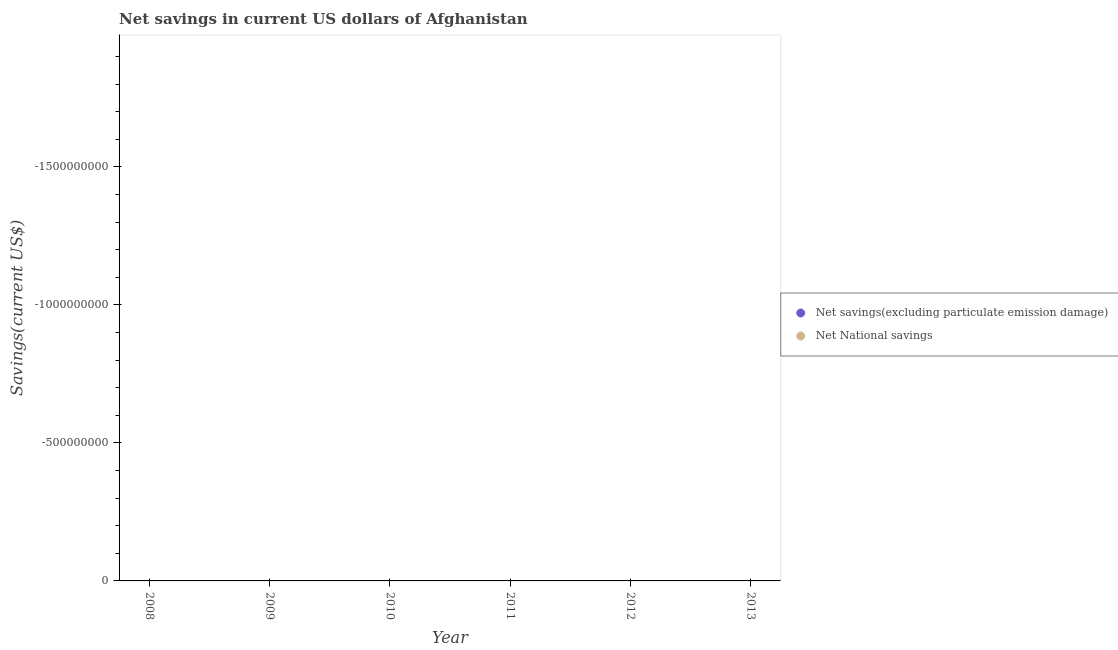How many different coloured dotlines are there?
Your response must be concise. 0. Across all years, what is the minimum net national savings?
Give a very brief answer. 0. What is the average net national savings per year?
Provide a succinct answer. 0. How many dotlines are there?
Make the answer very short. 0. How many years are there in the graph?
Ensure brevity in your answer.  6. What is the difference between two consecutive major ticks on the Y-axis?
Offer a very short reply. 5.00e+08. Does the graph contain any zero values?
Your response must be concise. Yes. Where does the legend appear in the graph?
Provide a succinct answer. Center right. How many legend labels are there?
Give a very brief answer. 2. What is the title of the graph?
Provide a succinct answer. Net savings in current US dollars of Afghanistan. Does "Investment" appear as one of the legend labels in the graph?
Make the answer very short. No. What is the label or title of the X-axis?
Give a very brief answer. Year. What is the label or title of the Y-axis?
Provide a short and direct response. Savings(current US$). What is the Savings(current US$) in Net savings(excluding particulate emission damage) in 2009?
Ensure brevity in your answer.  0. What is the Savings(current US$) in Net National savings in 2009?
Offer a very short reply. 0. What is the Savings(current US$) of Net savings(excluding particulate emission damage) in 2010?
Your answer should be compact. 0. What is the Savings(current US$) in Net National savings in 2010?
Offer a terse response. 0. What is the Savings(current US$) of Net National savings in 2011?
Keep it short and to the point. 0. What is the total Savings(current US$) of Net savings(excluding particulate emission damage) in the graph?
Your response must be concise. 0. What is the total Savings(current US$) in Net National savings in the graph?
Give a very brief answer. 0. 